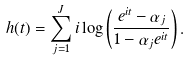<formula> <loc_0><loc_0><loc_500><loc_500>h ( t ) = \sum _ { j = 1 } ^ { J } i \log \left ( \frac { e ^ { i t } - \alpha _ { j } } { 1 - \alpha _ { j } e ^ { i t } } \right ) .</formula> 